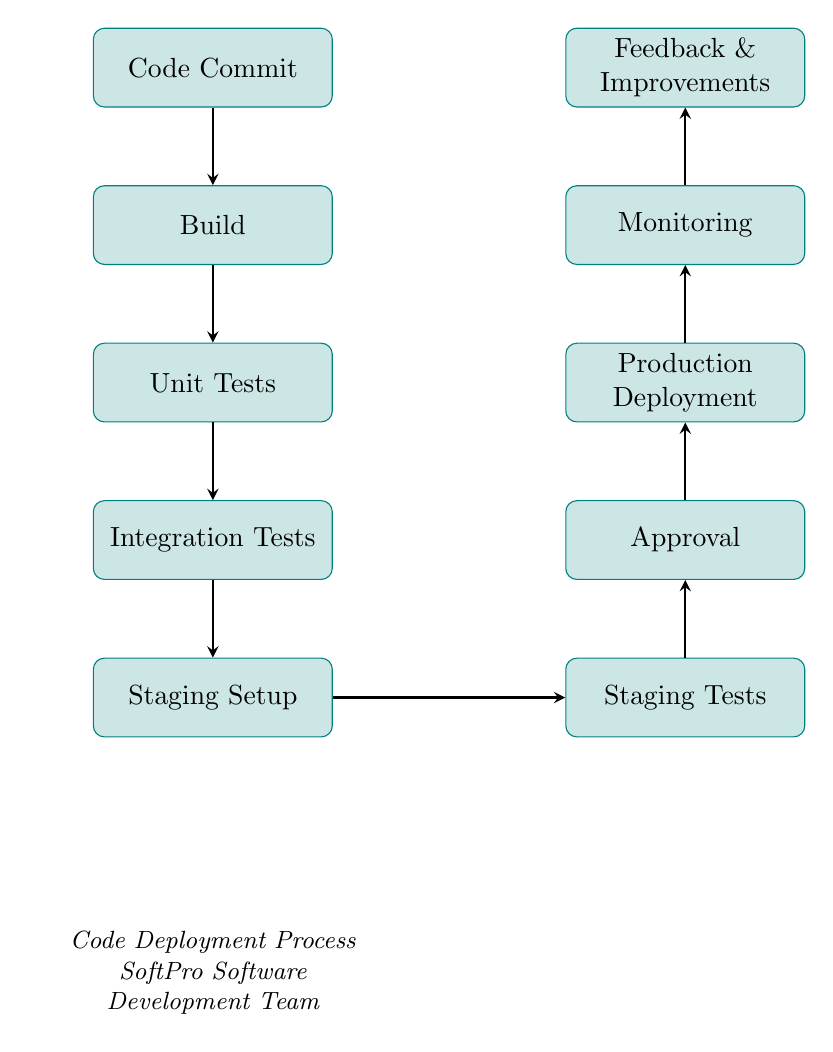What is the first step in the code deployment process? The diagram clearly shows that the first node is "Code Commit," which is the initial step in the flowchart.
Answer: Code Commit How many testing phases are there in the diagram? The diagram illustrates two specific testing phases: "Unit Tests" and "Integration Tests," which can be counted directly from the flowchart nodes.
Answer: 2 What follows the Staging Setup in the process? According to the flowchart, after the "Staging Setup," the next step that follows is "Staging Tests," which flows directly from the Staging Setup node.
Answer: Staging Tests Which phase is situated directly above the Approval phase? The diagram indicates that "Production Deployment" is the phase located directly above the "Approval" node within the flowchart structure.
Answer: Production Deployment What is the last phase in the code deployment process? It can be observed in the diagram that the final phase in the flowchart is "Feedback & Improvements," which is the topmost node in the vertical sequence.
Answer: Feedback & Improvements How many arrows connect different phases in the flowchart? By reviewing the layout of the diagram, we can count a total of eight arrows that indicate the flow of the various phases from start to finish.
Answer: 8 What is the sequence of the first four phases in the diagram? The first four phases, in order, are "Code Commit," "Build," "Unit Tests," and "Integration Tests." Each phase directly follows the previous one as shown in the flowchart.
Answer: Code Commit, Build, Unit Tests, Integration Tests What is the relationship between Staging Setup and Staging Tests? The diagram demonstrates a direct connection, with an arrow flowing from "Staging Setup" to "Staging Tests," indicating that the testing occurs after the staging setup.
Answer: Directly connected What is the primary focus of the diagram based on its caption? The caption at the bottom of the diagram states "Code Deployment Process SoftPro Software Development Team," indicating that the main focus is on illustrating the deployment process specifically for the team.
Answer: Code Deployment Process 